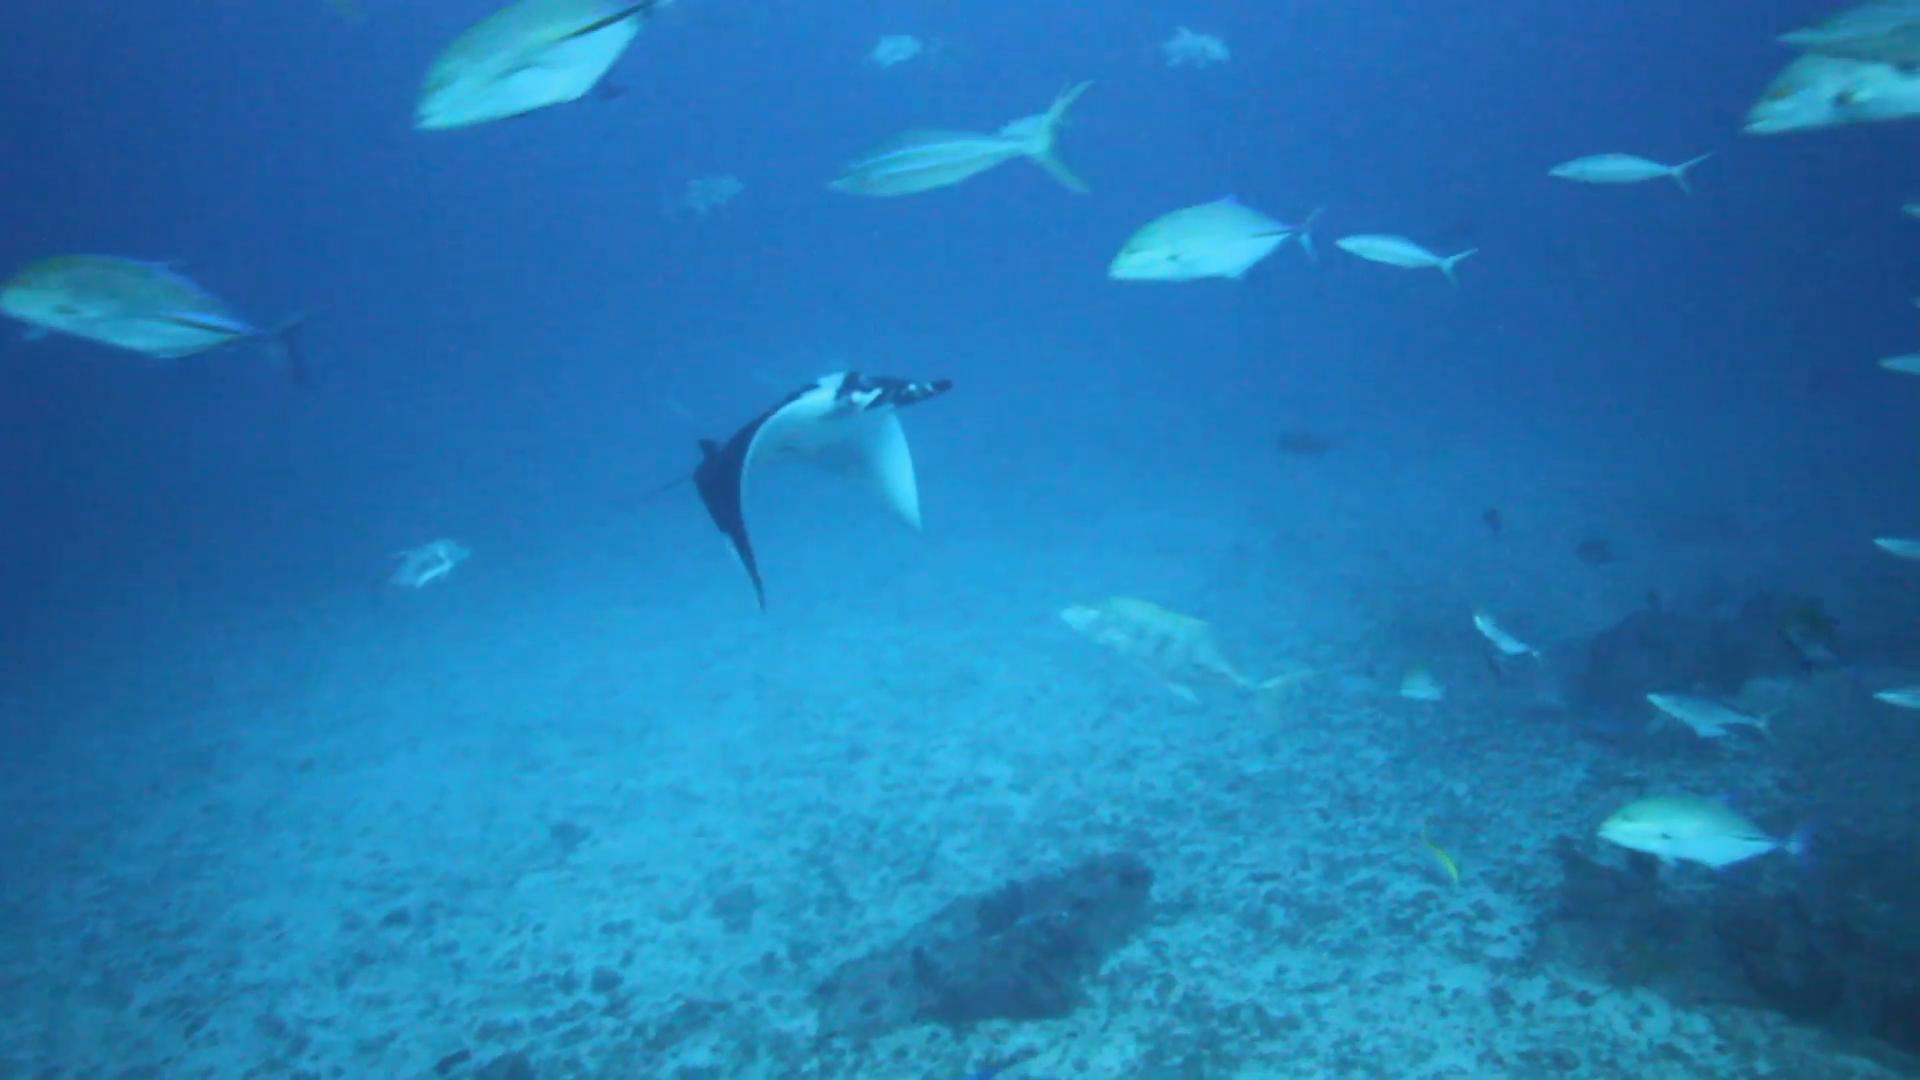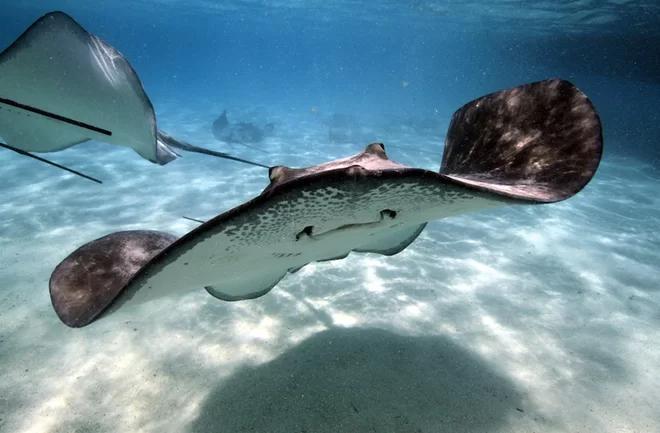The first image is the image on the left, the second image is the image on the right. For the images displayed, is the sentence "There is one human in the left image." factually correct? Answer yes or no. No. The first image is the image on the left, the second image is the image on the right. For the images shown, is this caption "There is at least one person snorkeling in the water near one or more sting rays" true? Answer yes or no. No. 